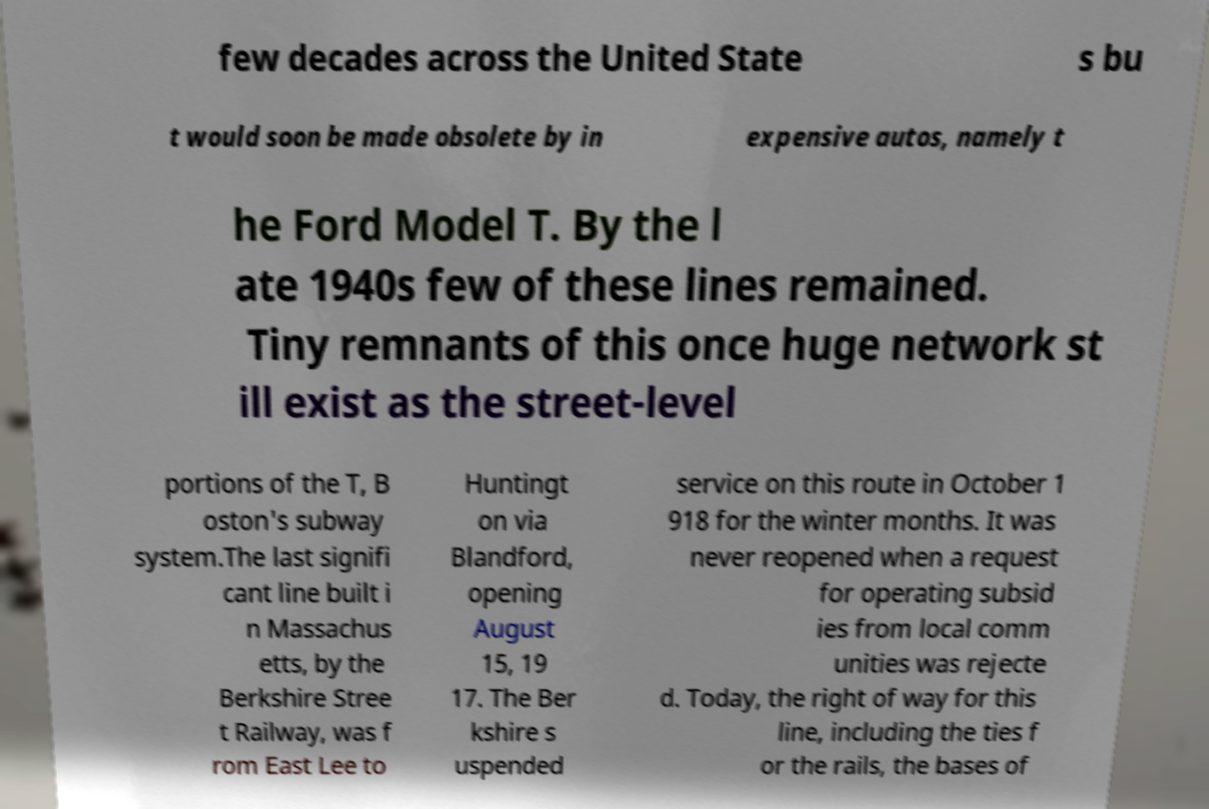Please read and relay the text visible in this image. What does it say? few decades across the United State s bu t would soon be made obsolete by in expensive autos, namely t he Ford Model T. By the l ate 1940s few of these lines remained. Tiny remnants of this once huge network st ill exist as the street-level portions of the T, B oston's subway system.The last signifi cant line built i n Massachus etts, by the Berkshire Stree t Railway, was f rom East Lee to Huntingt on via Blandford, opening August 15, 19 17. The Ber kshire s uspended service on this route in October 1 918 for the winter months. It was never reopened when a request for operating subsid ies from local comm unities was rejecte d. Today, the right of way for this line, including the ties f or the rails, the bases of 